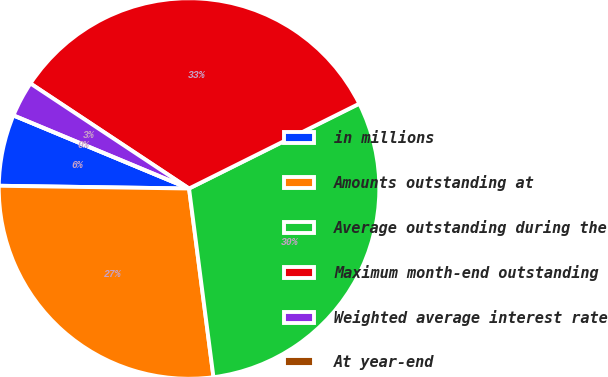Convert chart. <chart><loc_0><loc_0><loc_500><loc_500><pie_chart><fcel>in millions<fcel>Amounts outstanding at<fcel>Average outstanding during the<fcel>Maximum month-end outstanding<fcel>Weighted average interest rate<fcel>At year-end<nl><fcel>6.05%<fcel>27.28%<fcel>30.31%<fcel>33.33%<fcel>3.03%<fcel>0.0%<nl></chart> 